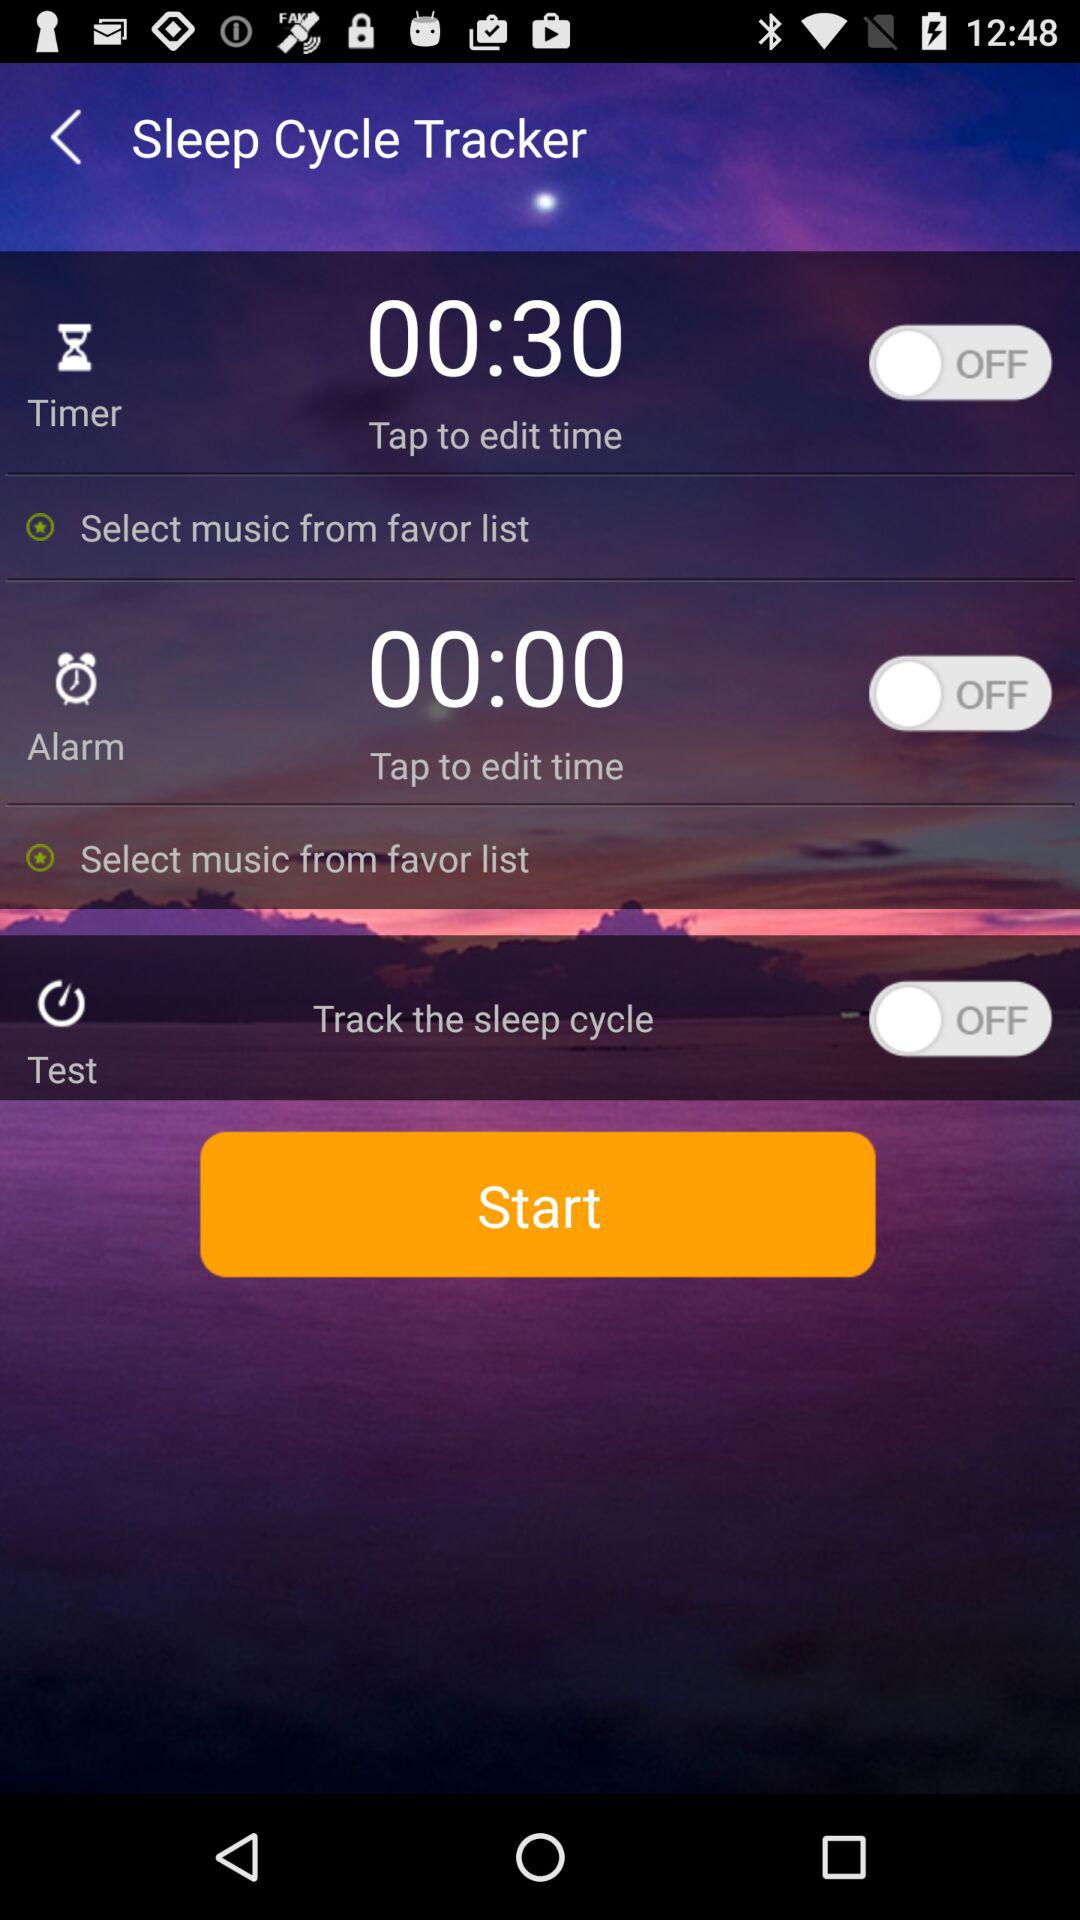What is the status of "Track the sleep cycle"? The status is off. 